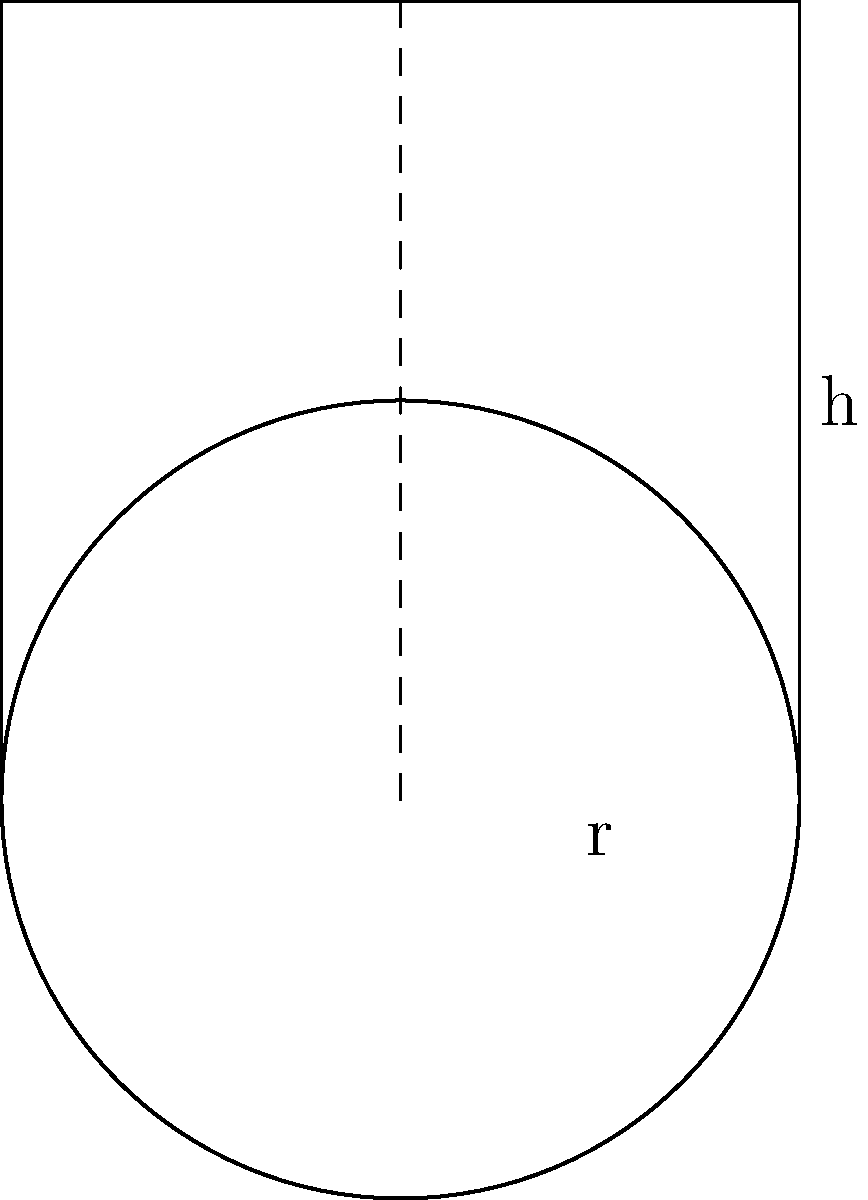As a busy parent, you want to optimize food storage in your kitchen. You have a cylindrical container with a radius of 5 inches and a height of 10 inches. Calculate the volume of this container in cubic inches to determine how much food it can hold. Round your answer to the nearest whole number. To calculate the volume of a cylindrical container, we use the formula:

$$ V = \pi r^2 h $$

Where:
$V$ = volume
$r$ = radius
$h$ = height

Given:
$r = 5$ inches
$h = 10$ inches

Step 1: Substitute the values into the formula:
$$ V = \pi (5^2) (10) $$

Step 2: Calculate the square of the radius:
$$ V = \pi (25) (10) $$

Step 3: Multiply the values:
$$ V = \pi (250) $$

Step 4: Calculate the final value (use 3.14159 for $\pi$):
$$ V = 3.14159 \times 250 = 785.3975 \text{ cubic inches} $$

Step 5: Round to the nearest whole number:
$$ V \approx 785 \text{ cubic inches} $$
Answer: 785 cubic inches 